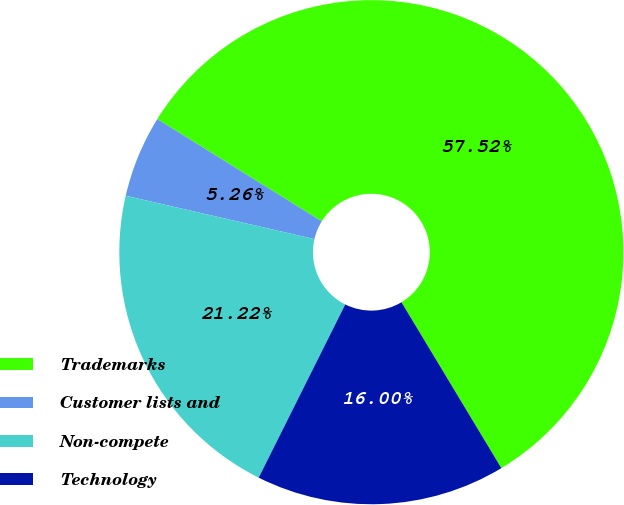Convert chart to OTSL. <chart><loc_0><loc_0><loc_500><loc_500><pie_chart><fcel>Trademarks<fcel>Customer lists and<fcel>Non-compete<fcel>Technology<nl><fcel>57.52%<fcel>5.26%<fcel>21.22%<fcel>16.0%<nl></chart> 